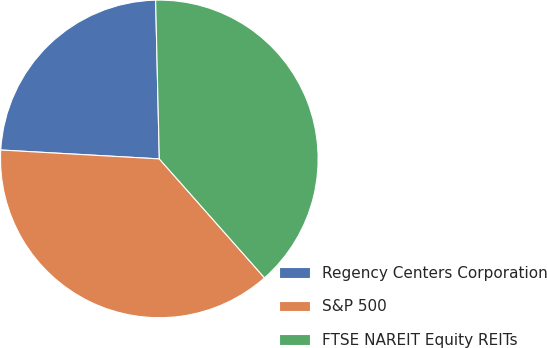Convert chart to OTSL. <chart><loc_0><loc_0><loc_500><loc_500><pie_chart><fcel>Regency Centers Corporation<fcel>S&P 500<fcel>FTSE NAREIT Equity REITs<nl><fcel>23.74%<fcel>37.42%<fcel>38.84%<nl></chart> 